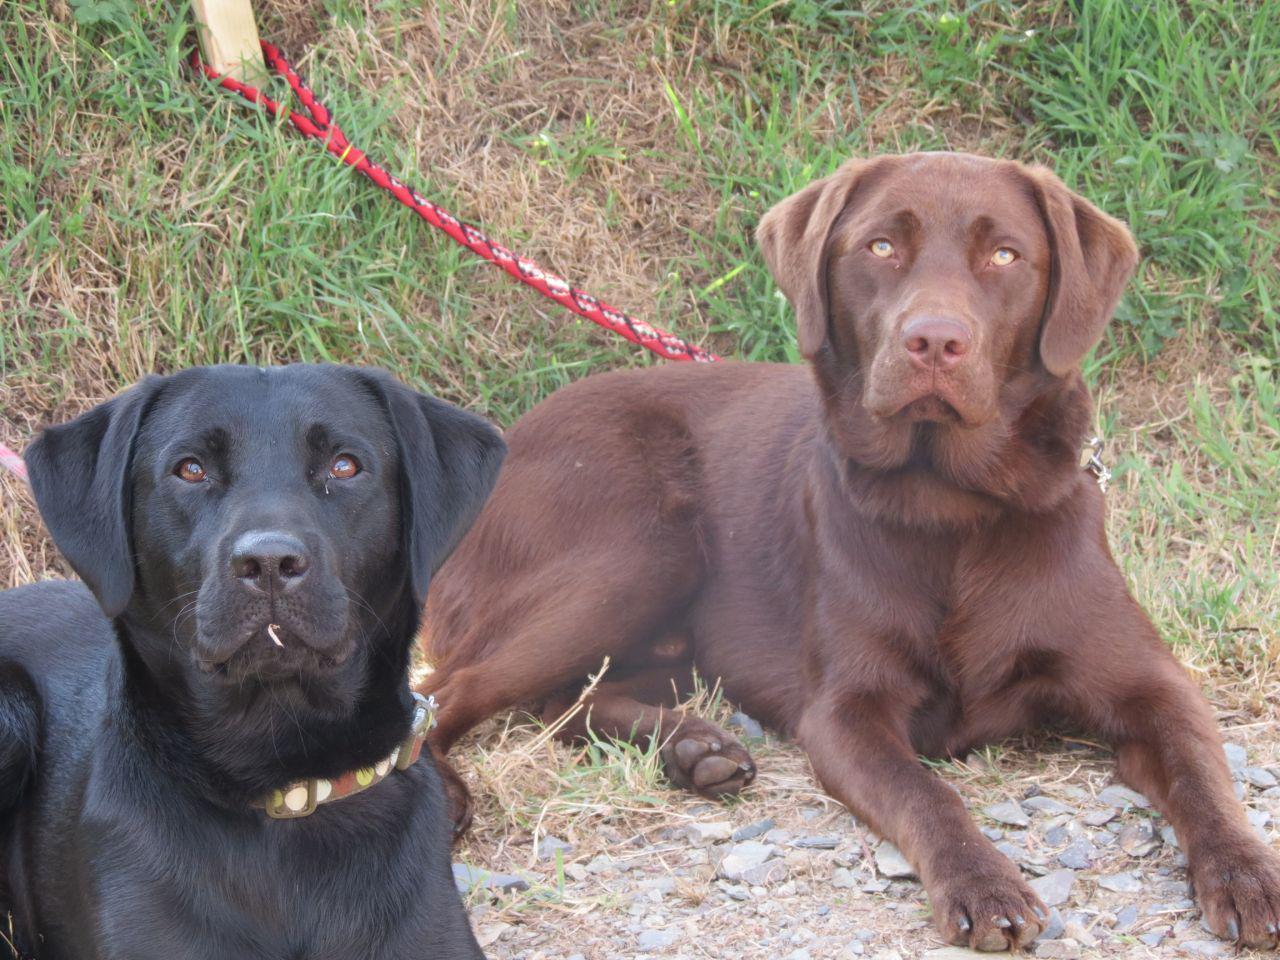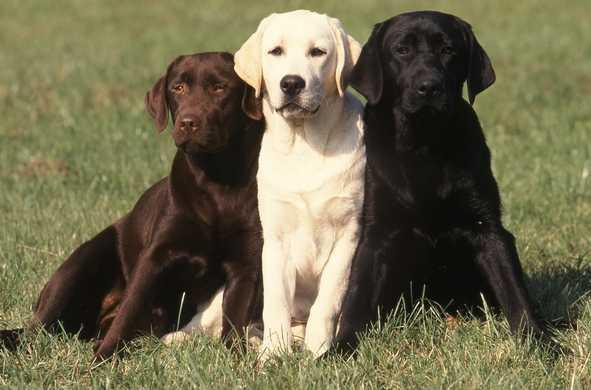The first image is the image on the left, the second image is the image on the right. Examine the images to the left and right. Is the description "There are the same number of dogs in each image, but they are a different age in one image than the other." accurate? Answer yes or no. No. The first image is the image on the left, the second image is the image on the right. Evaluate the accuracy of this statement regarding the images: "One picture shows a brown dog, a light cream dog, and a black dog next to each other, with the light dog in the middle.". Is it true? Answer yes or no. Yes. 